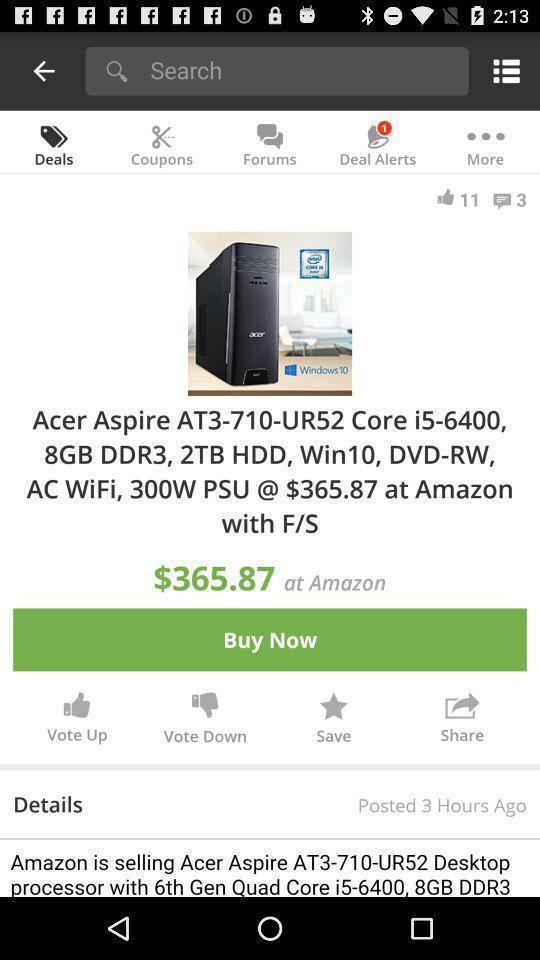Provide a detailed account of this screenshot. Page that displaying shopping application. 